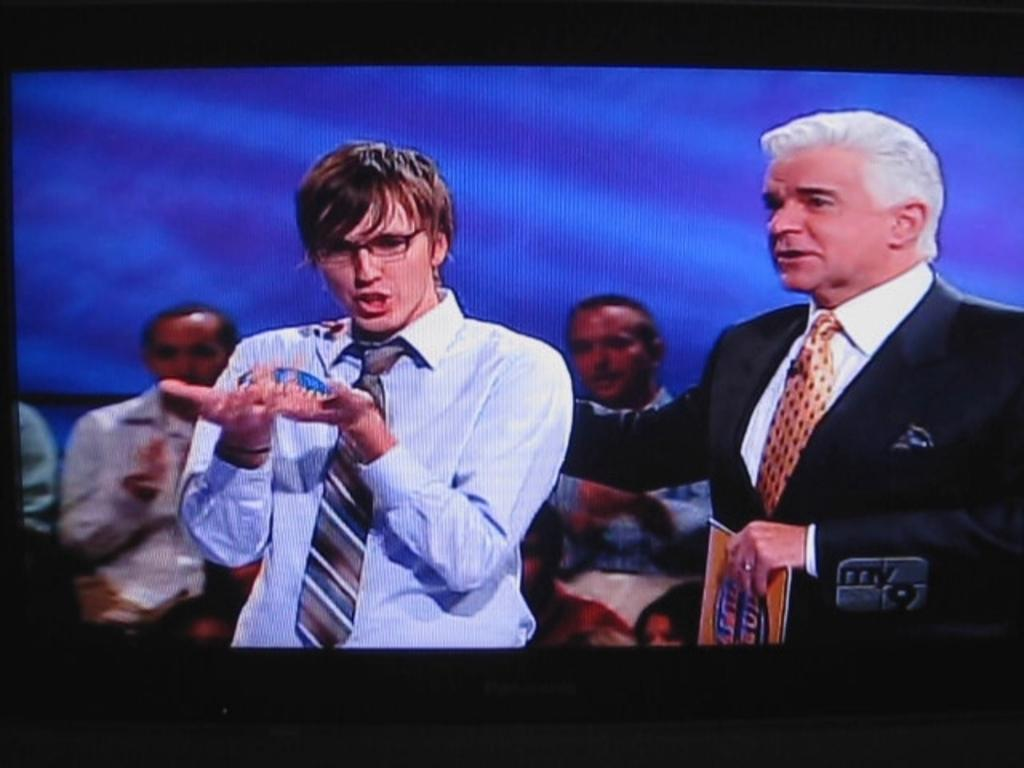How many people are standing in the image? There are two people standing in the image. What is the man on the right holding? The man standing on the right is holding a paper. Can you describe the people in the background of the image? There are people sitting in the background of the image. What type of territory is being claimed by the people in the image? There is no indication in the image that the people are claiming any territory. 